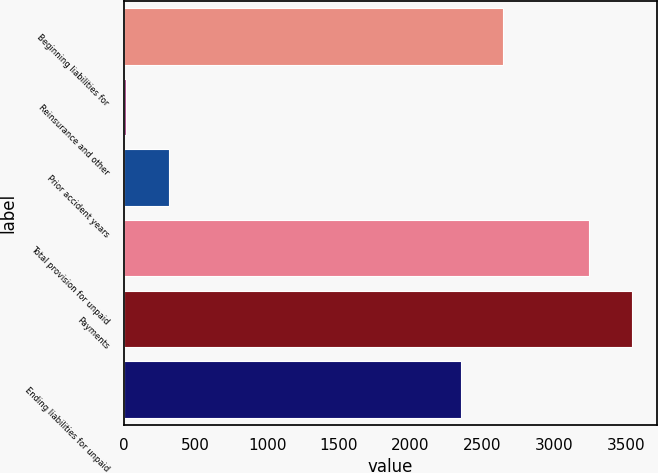Convert chart to OTSL. <chart><loc_0><loc_0><loc_500><loc_500><bar_chart><fcel>Beginning liabilities for<fcel>Reinsurance and other<fcel>Prior accident years<fcel>Total provision for unpaid<fcel>Payments<fcel>Ending liabilities for unpaid<nl><fcel>2647.4<fcel>17<fcel>314.7<fcel>3242.8<fcel>3540.5<fcel>2349.7<nl></chart> 